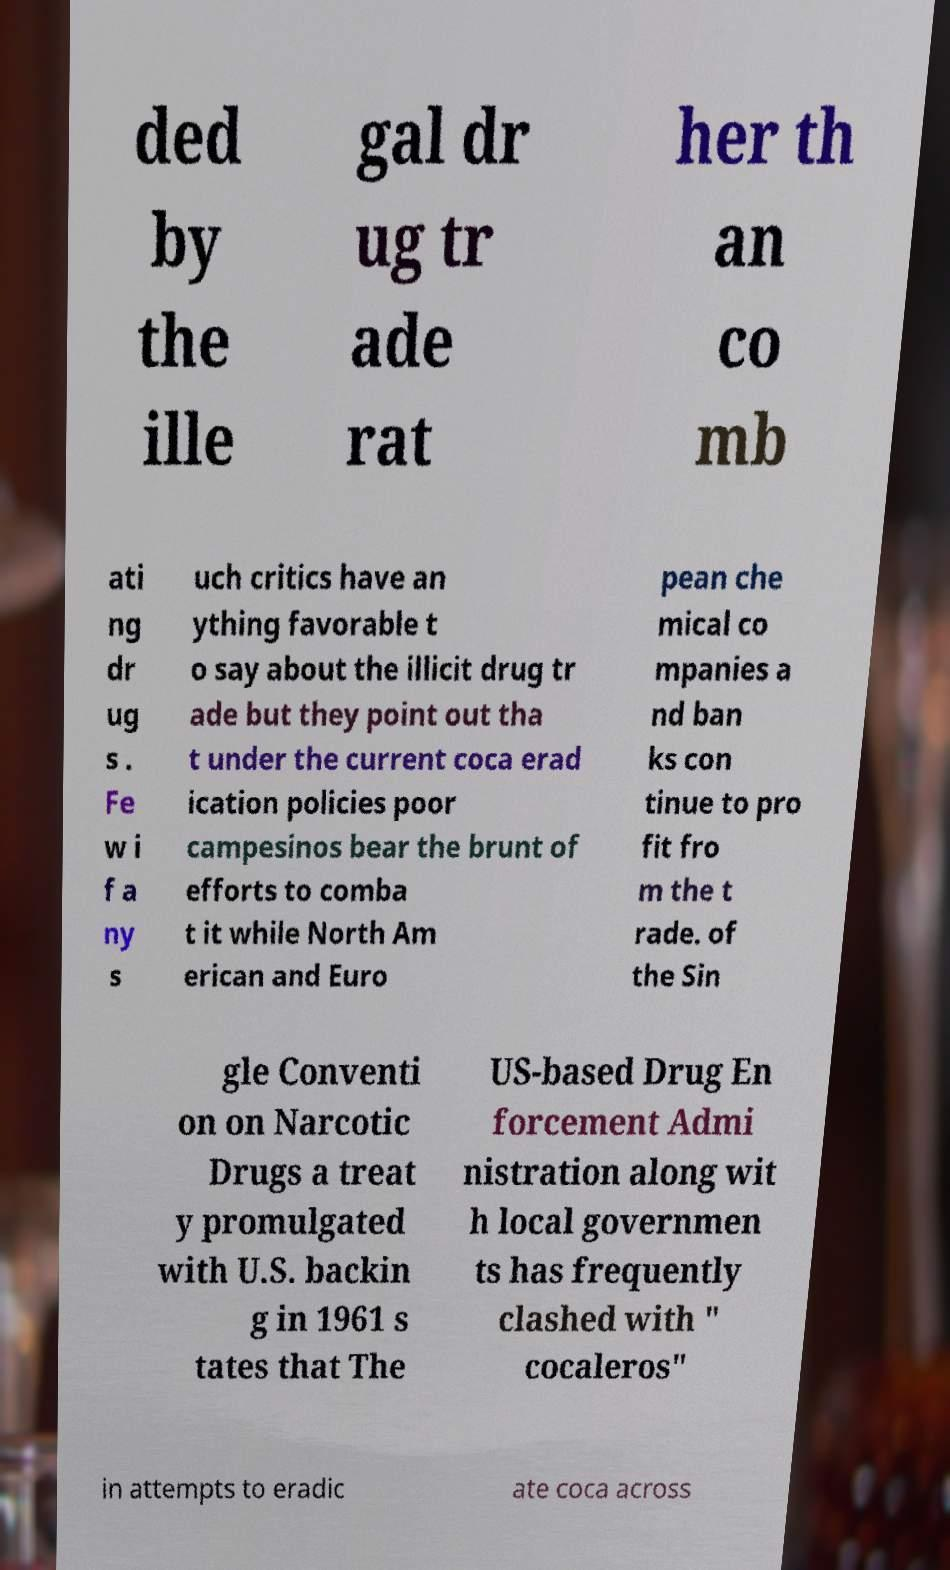Can you read and provide the text displayed in the image?This photo seems to have some interesting text. Can you extract and type it out for me? ded by the ille gal dr ug tr ade rat her th an co mb ati ng dr ug s . Fe w i f a ny s uch critics have an ything favorable t o say about the illicit drug tr ade but they point out tha t under the current coca erad ication policies poor campesinos bear the brunt of efforts to comba t it while North Am erican and Euro pean che mical co mpanies a nd ban ks con tinue to pro fit fro m the t rade. of the Sin gle Conventi on on Narcotic Drugs a treat y promulgated with U.S. backin g in 1961 s tates that The US-based Drug En forcement Admi nistration along wit h local governmen ts has frequently clashed with " cocaleros" in attempts to eradic ate coca across 